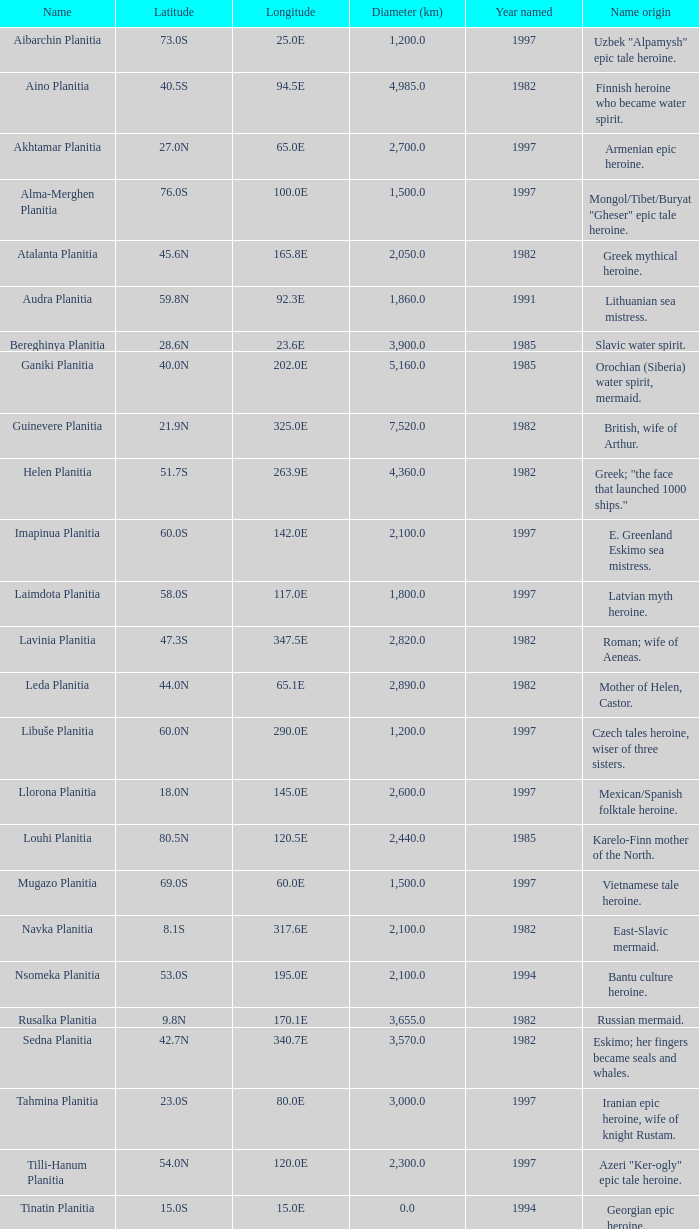What is the diameter (km) of longitude 170.1e 3655.0. 